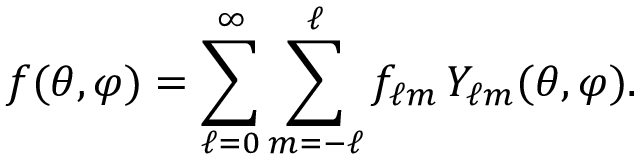Convert formula to latex. <formula><loc_0><loc_0><loc_500><loc_500>f ( \theta , \varphi ) = \sum _ { \ell = 0 } ^ { \infty } \sum _ { m = - \ell } ^ { \ell } f _ { \ell m } \, Y _ { \ell m } ( \theta , \varphi ) .</formula> 